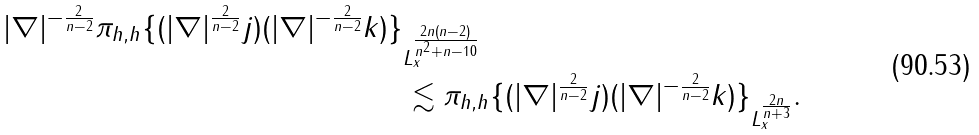<formula> <loc_0><loc_0><loc_500><loc_500>\| | \nabla | ^ { - \frac { 2 } { n - 2 } } \pi _ { h , h } \{ ( | \nabla | ^ { \frac { 2 } { n - 2 } } j ) ( | \nabla | ^ { - \frac { 2 } { n - 2 } } k ) \} & \| _ { L _ { x } ^ { \frac { 2 n ( n - 2 ) } { n ^ { 2 } + n - 1 0 } } } \\ & \lesssim \| \pi _ { h , h } \{ ( | \nabla | ^ { \frac { 2 } { n - 2 } } j ) ( | \nabla | ^ { - \frac { 2 } { n - 2 } } k ) \} \| _ { L _ { x } ^ { \frac { 2 n } { n + 3 } } } .</formula> 